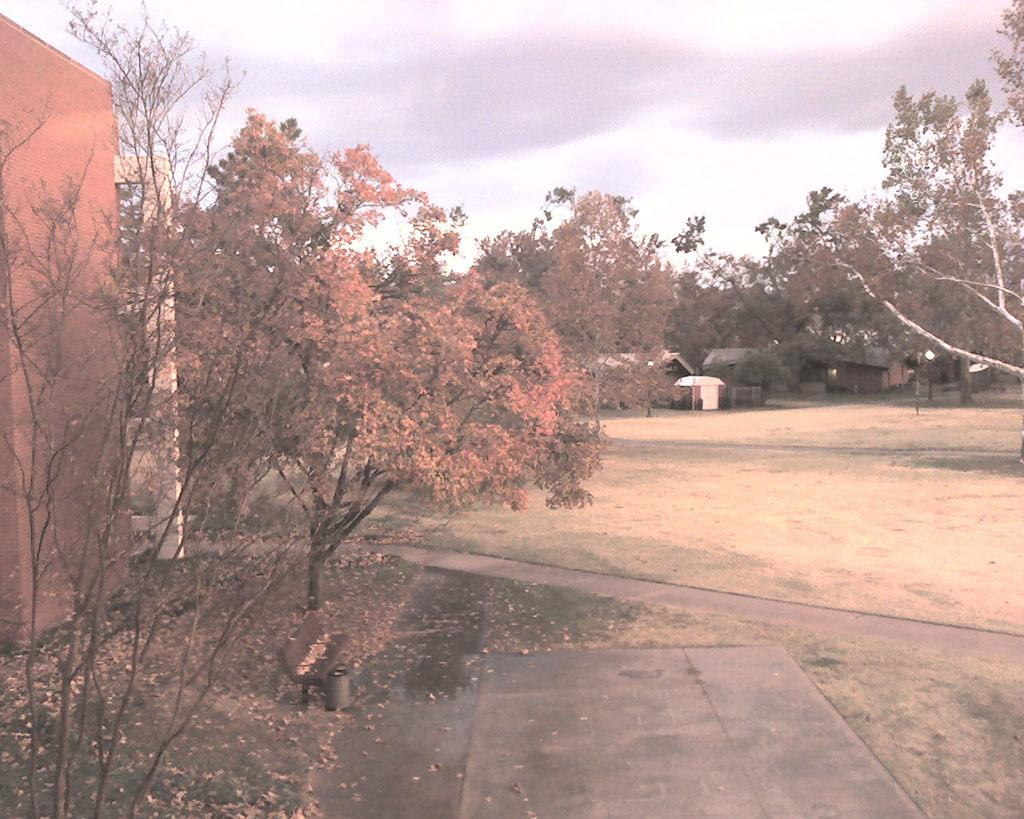What can be seen in the foreground of the image? There is a pavement and grass land in the foreground of the image. What is located on the left side of the image? There are trees and a wall on the left side of the image. What is visible in the background of the image? There are trees, houses, and clouds visible in the background of the image. Can you tell me how many crackers are being fed to the pigs in the image? There are no crackers or pigs present in the image. What type of poison is being used to control the tree growth in the image? There is no mention of poison or tree growth control in the image. 